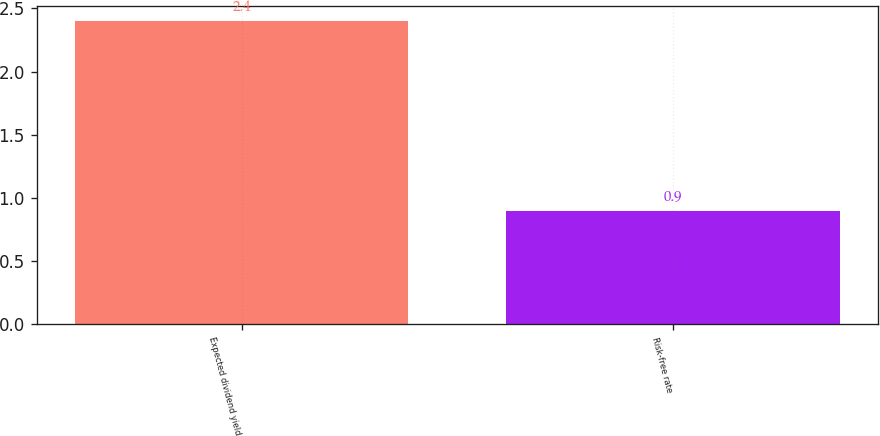Convert chart to OTSL. <chart><loc_0><loc_0><loc_500><loc_500><bar_chart><fcel>Expected dividend yield<fcel>Risk-free rate<nl><fcel>2.4<fcel>0.9<nl></chart> 